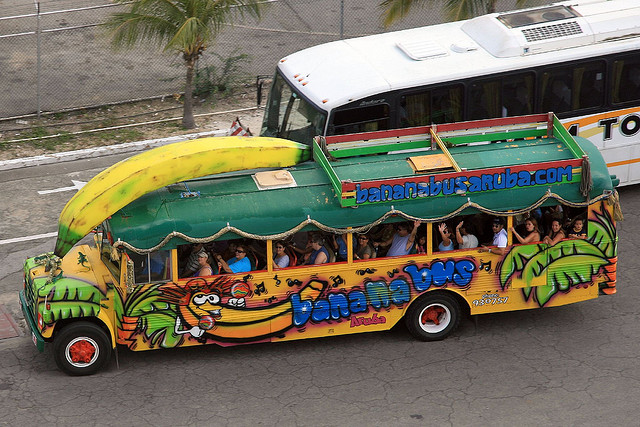Read and extract the text from this image. Afuba banana bus TO 